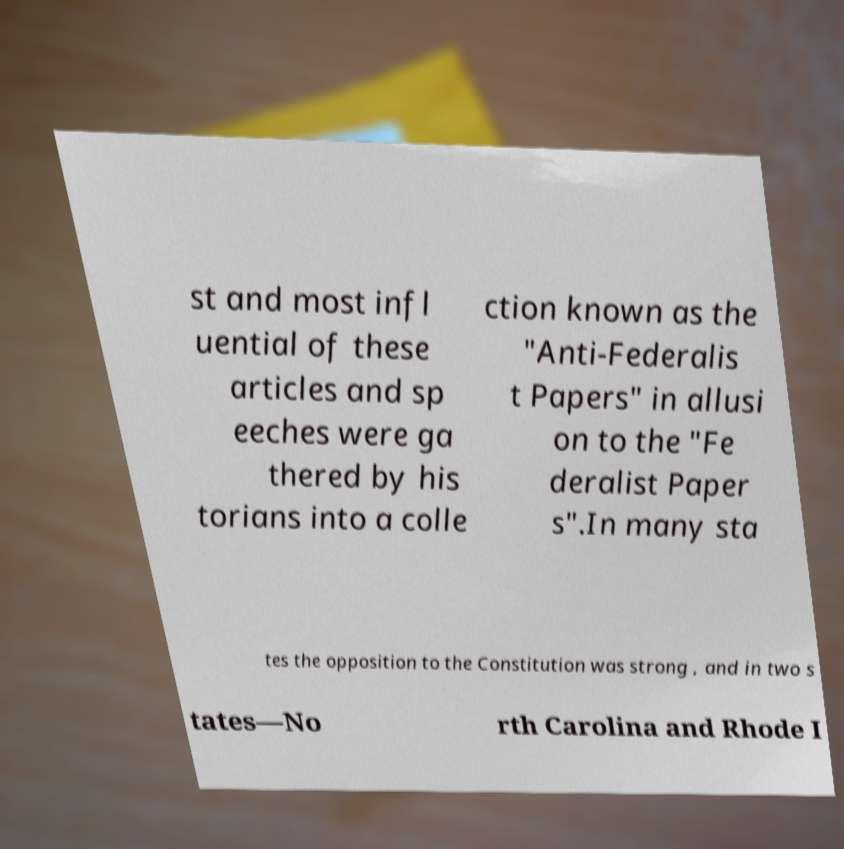Could you assist in decoding the text presented in this image and type it out clearly? st and most infl uential of these articles and sp eeches were ga thered by his torians into a colle ction known as the "Anti-Federalis t Papers" in allusi on to the "Fe deralist Paper s".In many sta tes the opposition to the Constitution was strong , and in two s tates—No rth Carolina and Rhode I 